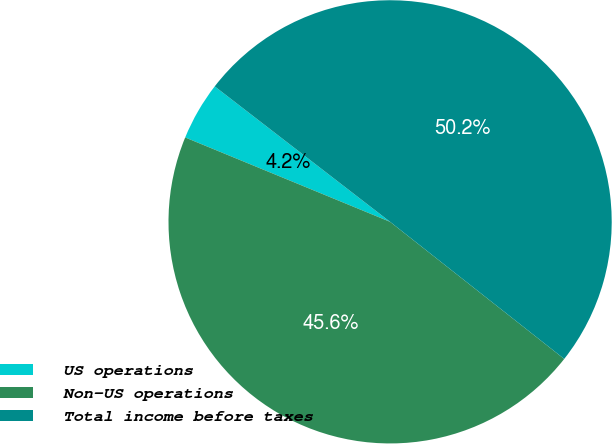<chart> <loc_0><loc_0><loc_500><loc_500><pie_chart><fcel>US operations<fcel>Non-US operations<fcel>Total income before taxes<nl><fcel>4.25%<fcel>45.6%<fcel>50.15%<nl></chart> 